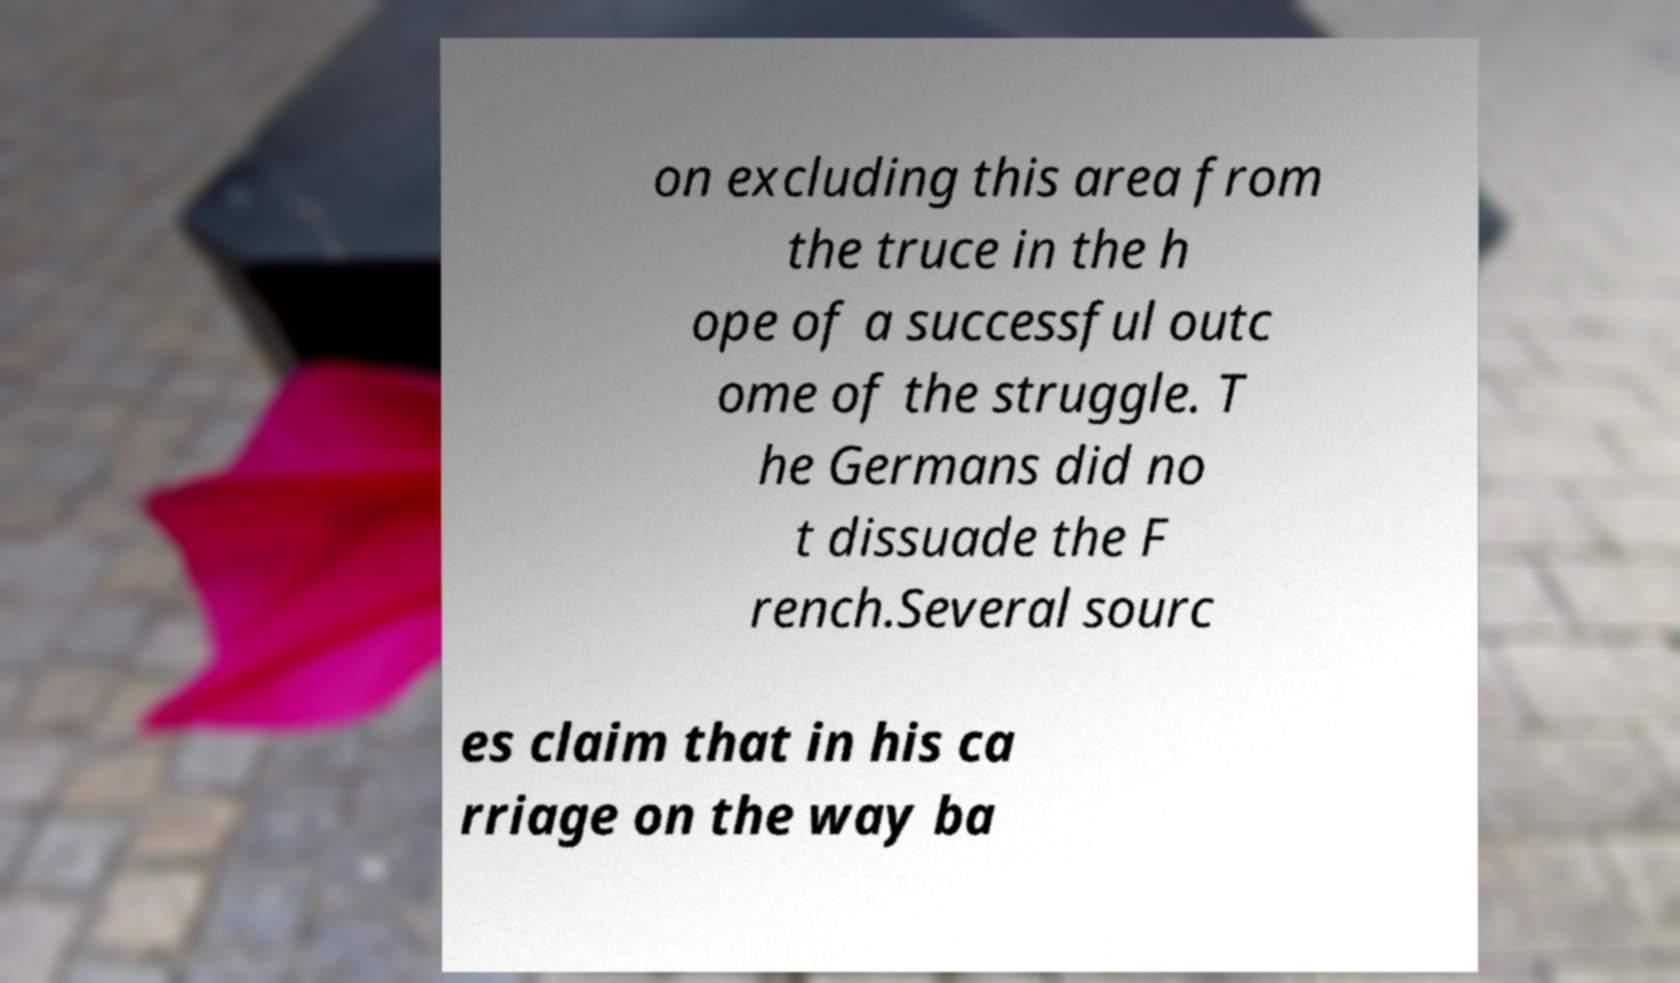There's text embedded in this image that I need extracted. Can you transcribe it verbatim? on excluding this area from the truce in the h ope of a successful outc ome of the struggle. T he Germans did no t dissuade the F rench.Several sourc es claim that in his ca rriage on the way ba 